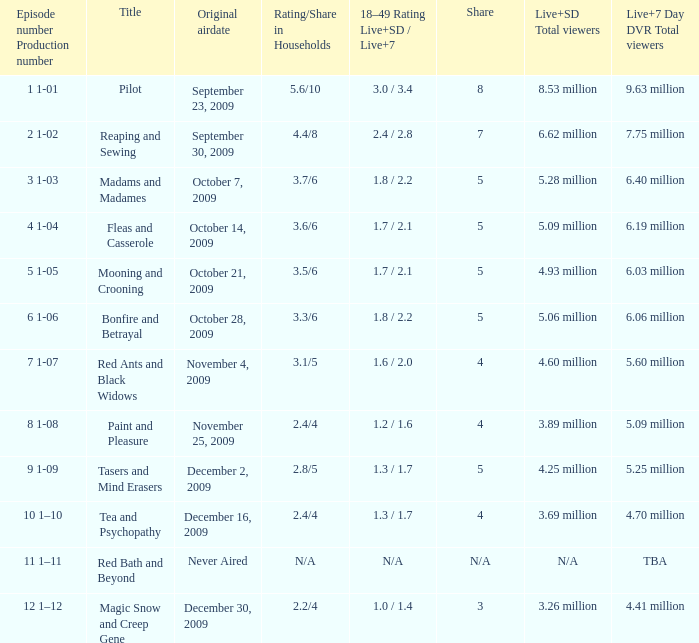69 million total viewers (live and sd types combined) initially broadcasted? December 16, 2009. 